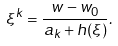<formula> <loc_0><loc_0><loc_500><loc_500>\xi ^ { k } = \frac { w - w _ { 0 } } { a _ { k } + h ( \xi ) } .</formula> 